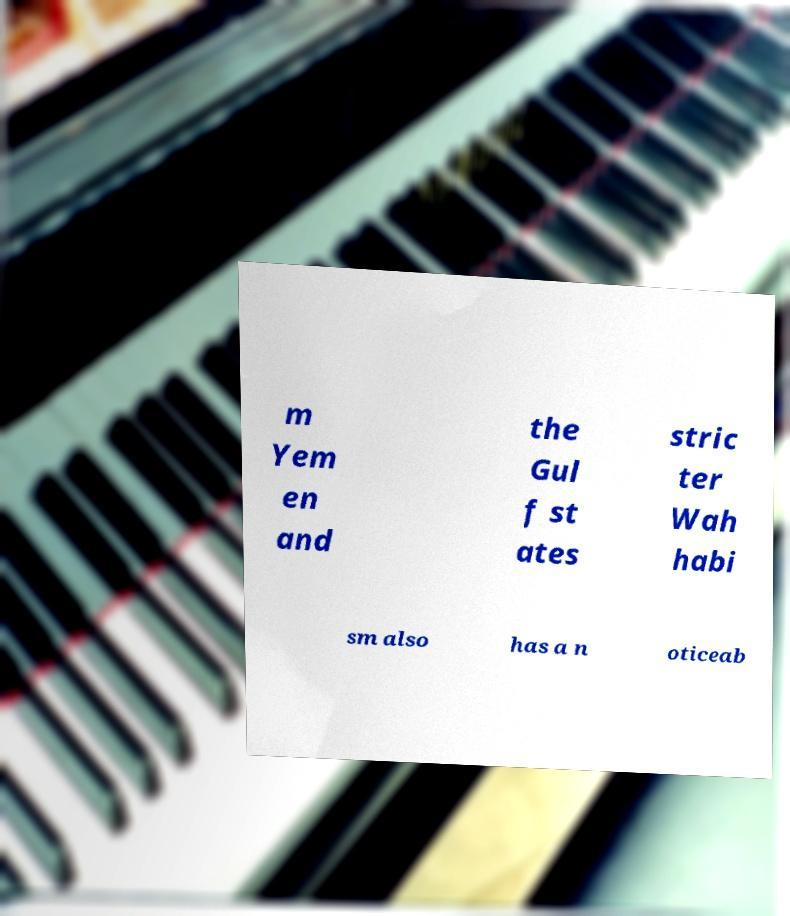Can you read and provide the text displayed in the image?This photo seems to have some interesting text. Can you extract and type it out for me? m Yem en and the Gul f st ates stric ter Wah habi sm also has a n oticeab 